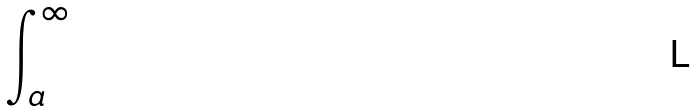Convert formula to latex. <formula><loc_0><loc_0><loc_500><loc_500>\int _ { a } ^ { \infty }</formula> 